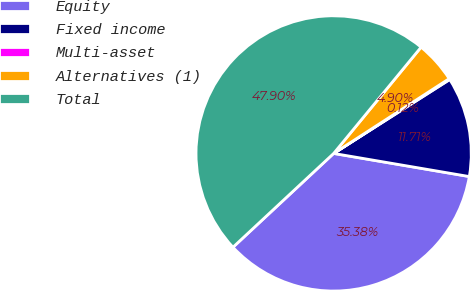Convert chart to OTSL. <chart><loc_0><loc_0><loc_500><loc_500><pie_chart><fcel>Equity<fcel>Fixed income<fcel>Multi-asset<fcel>Alternatives (1)<fcel>Total<nl><fcel>35.38%<fcel>11.71%<fcel>0.12%<fcel>4.9%<fcel>47.9%<nl></chart> 